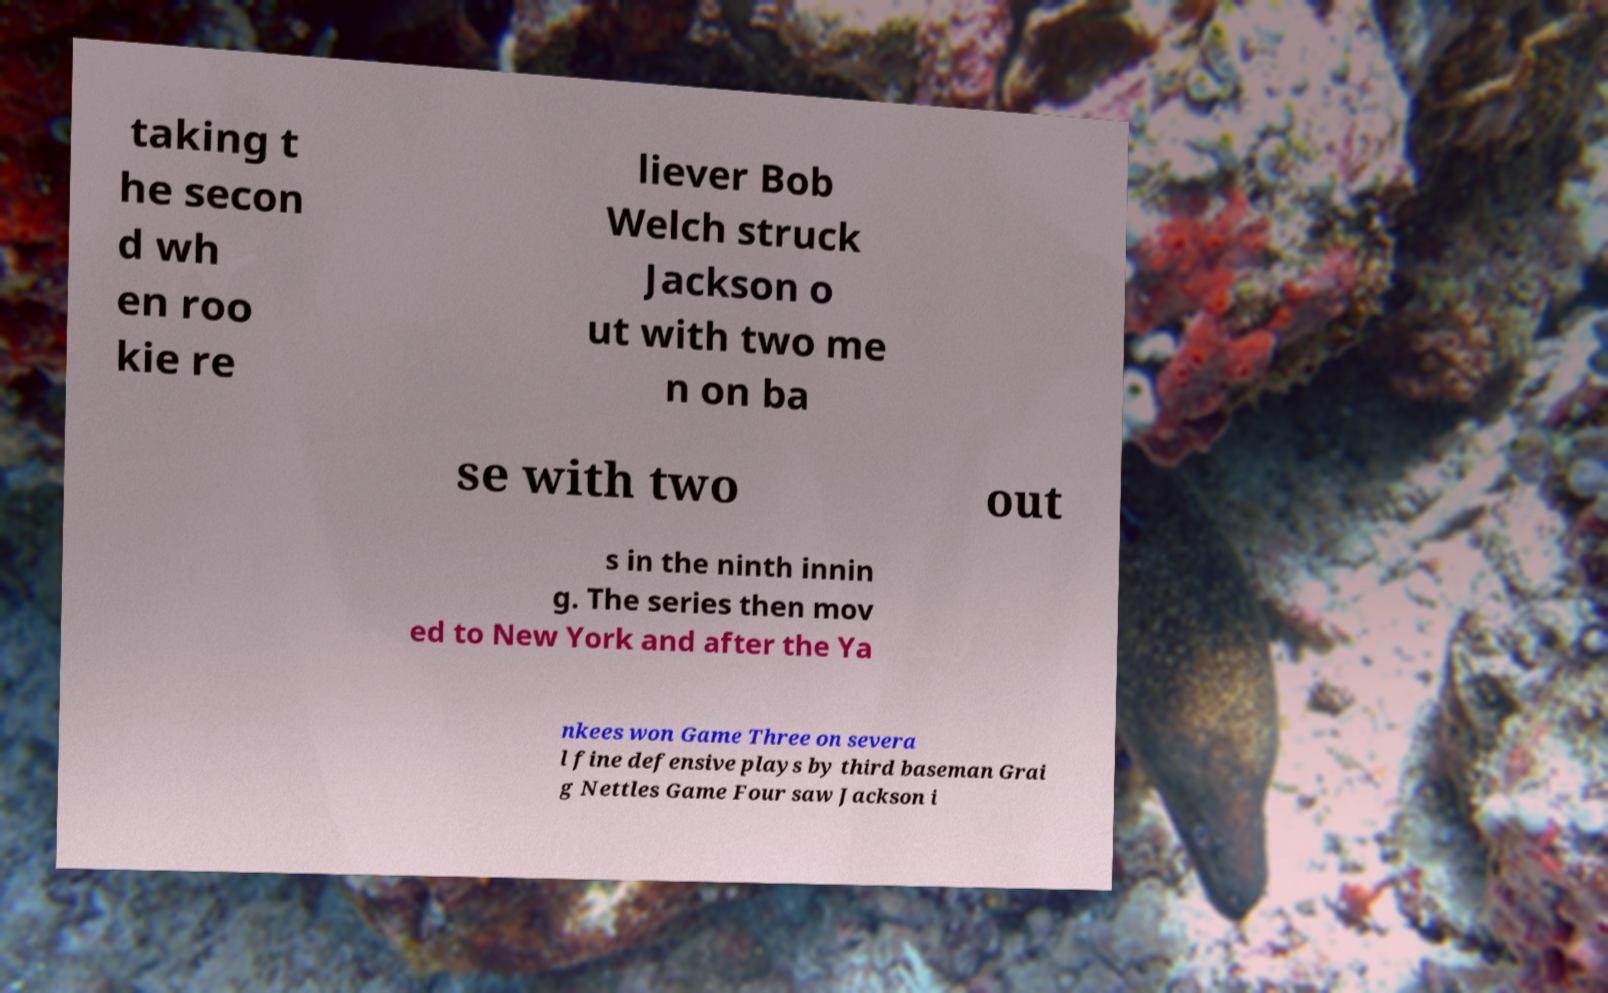Can you read and provide the text displayed in the image?This photo seems to have some interesting text. Can you extract and type it out for me? taking t he secon d wh en roo kie re liever Bob Welch struck Jackson o ut with two me n on ba se with two out s in the ninth innin g. The series then mov ed to New York and after the Ya nkees won Game Three on severa l fine defensive plays by third baseman Grai g Nettles Game Four saw Jackson i 